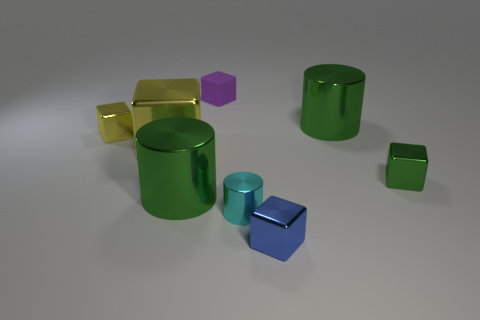Subtract all tiny yellow cubes. How many cubes are left? 4 Subtract all purple cubes. How many cubes are left? 4 Add 2 small metallic cylinders. How many objects exist? 10 Subtract all blocks. How many objects are left? 3 Subtract 2 cylinders. How many cylinders are left? 1 Add 6 small yellow shiny cubes. How many small yellow shiny cubes exist? 7 Subtract 0 green spheres. How many objects are left? 8 Subtract all red blocks. Subtract all green spheres. How many blocks are left? 5 Subtract all gray spheres. How many yellow cylinders are left? 0 Subtract all green objects. Subtract all large green shiny objects. How many objects are left? 3 